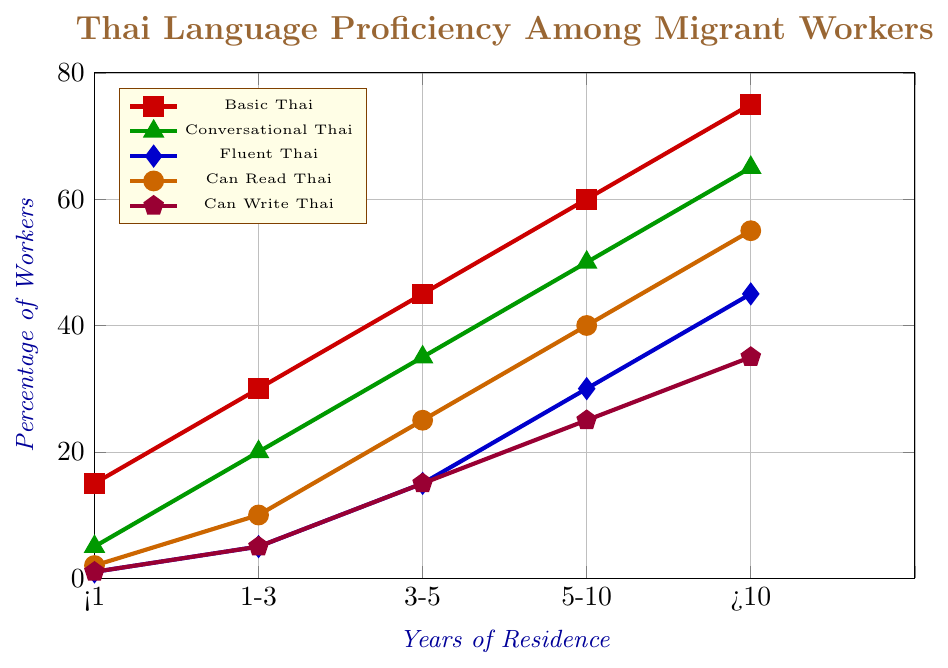How many more migrant workers can speak Fluent Thai compared to Conversational Thai after more than 10 years of residence? Look at the values of Fluent Thai and Conversational Thai after more than 10 years of residence. Fluent Thai is 45%, and Conversational Thai is 65%. Calculate the difference: 65 - 45 = 20
Answer: 20% What is the sum of the percentages of migrant workers who can Read and Write Thai after 3-5 years of residence? Look at the values for Can Read Thai and Can Write Thai after 3-5 years of residence: Can Read Thai is 25%, and Can Write Thai is 15%. Sum them up: 25 + 15 = 40
Answer: 40% Which Thai language proficiency level has the highest percentage of migrant workers who have been in Thailand for 1-3 years? Identify the highest value among all proficiency levels for 1-3 years of residence. Basic Thai is 30%, Conversational Thai is 20%, Fluent Thai is 5%, Can Read Thai is 10%, and Can Write Thai is 5%. The highest percentage is for Basic Thai at 30%
Answer: Basic Thai What is the average percentage of migrant workers who have Conversational, Fluent, and Basic Thai proficiency for those with 5-10 years of residence? Look at the values for 5-10 years of residence: Conversational Thai is 50%, Fluent Thai is 30%, and Basic Thai is 60%. Calculate the average: (50 + 30 + 60) / 3 = 140 / 3 = 46.67
Answer: 46.67% Is the percentage of migrant workers who can Read Thai greater than those who can Write Thai after 1-3 years of residence? Look at the values for Can Read Thai and Can Write Thai after 1-3 years of residence: Can Read Thai is 10%, and Can Write Thai is 5%. Compare the two values: 10% is greater than 5%
Answer: Yes By how much does the percentage of migrant workers who have Basic Thai proficiency increase from less than 1 year to more than 10 years of residence? Look at the values for Basic Thai proficiency for less than 1 year and more than 10 years of residence: less than 1 year is 15%, and more than 10 years is 75%. Calculate the increase: 75 - 15 = 60
Answer: 60% What is the trend in the percentage of migrant workers who can write Thai across different years of residence? Observe the values for Can Write Thai across different years of residence: Less than 1 year is 1%, 1-3 years is 5%, 3-5 years is 15%, 5-10 years is 25%, and more than 10 years is 35%. The trend shows a steady increase in the percentage over time
Answer: Increasing Which proficiency shows the lowest initial percentage and which one shows the highest final percentage according to the figure? Look at the initial percentages for all proficiencies and the final percentages for each. Fluent Thai has the lowest initial percentage at 1%, and Basic Thai has the highest final percentage at 75%
Answer: Fluent Thai, Basic Thai How does the percentage of migrant workers with Basic Thai proficiency change between each consecutive period of residence? Identify the values for Basic Thai proficiency: less than 1 year is 15%, 1-3 years is 30%, 3-5 years is 45%, 5-10 years is 60%, and more than 10 years is 75%. Calculate the changes: 30 - 15 = 15; 45 - 30 = 15; 60 - 45 = 15; 75 - 60 = 15
Answer: 15% (for each period) 